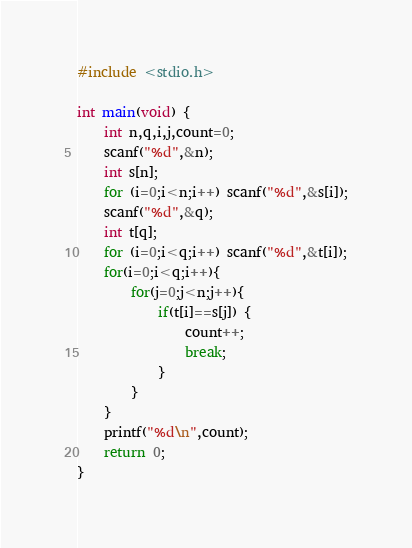<code> <loc_0><loc_0><loc_500><loc_500><_C_>#include <stdio.h>
 
int main(void) {
    int n,q,i,j,count=0;
    scanf("%d",&n);
    int s[n];
    for (i=0;i<n;i++) scanf("%d",&s[i]);
    scanf("%d",&q);
    int t[q];
    for (i=0;i<q;i++) scanf("%d",&t[i]);
    for(i=0;i<q;i++){
        for(j=0;j<n;j++){
            if(t[i]==s[j]) {
            	count++;
            	break;
            }
        }
    }
    printf("%d\n",count);
    return 0;
}</code> 